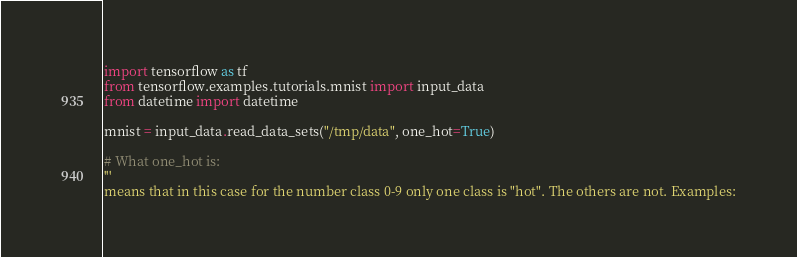<code> <loc_0><loc_0><loc_500><loc_500><_Python_>import tensorflow as tf
from tensorflow.examples.tutorials.mnist import input_data
from datetime import datetime

mnist = input_data.read_data_sets("/tmp/data", one_hot=True)

# What one_hot is:
'''
means that in this case for the number class 0-9 only one class is "hot". The others are not. Examples:</code> 